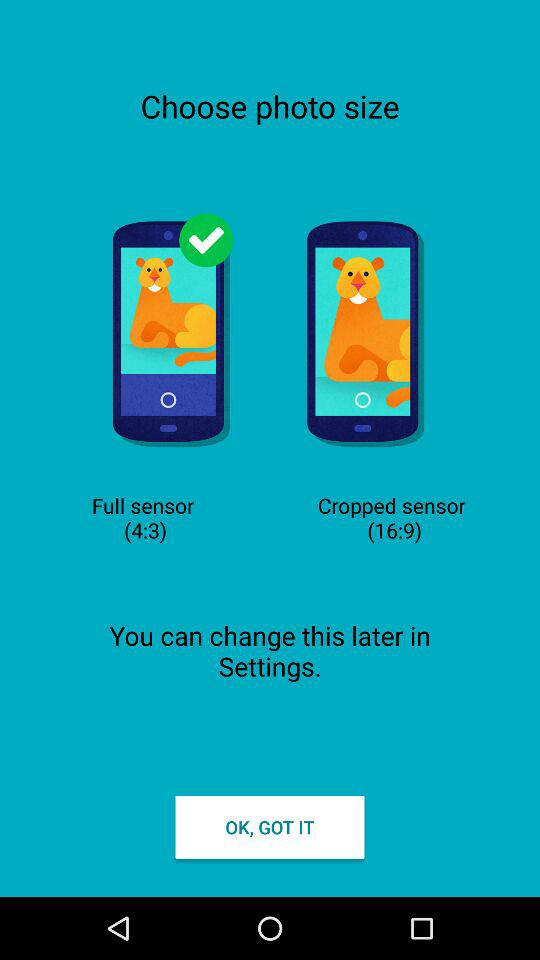What's the selected photo size? The selected photo size is 4:3. 